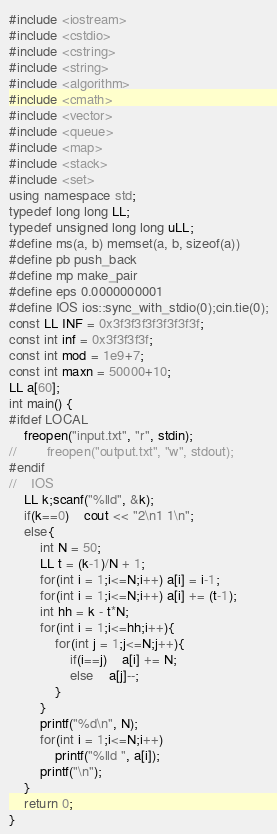<code> <loc_0><loc_0><loc_500><loc_500><_C++_>#include <iostream>
#include <cstdio>
#include <cstring>
#include <string>
#include <algorithm>
#include <cmath>
#include <vector>
#include <queue>
#include <map>
#include <stack>
#include <set>
using namespace std;
typedef long long LL;
typedef unsigned long long uLL;
#define ms(a, b) memset(a, b, sizeof(a))
#define pb push_back
#define mp make_pair
#define eps 0.0000000001
#define IOS ios::sync_with_stdio(0);cin.tie(0);
const LL INF = 0x3f3f3f3f3f3f3f3f;
const int inf = 0x3f3f3f3f;
const int mod = 1e9+7;
const int maxn = 50000+10;
LL a[60];
int main() {
#ifdef LOCAL
    freopen("input.txt", "r", stdin);
//        freopen("output.txt", "w", stdout);
#endif
//    IOS
    LL k;scanf("%lld", &k);
    if(k==0)    cout << "2\n1 1\n";
    else{
        int N = 50;
        LL t = (k-1)/N + 1;
        for(int i = 1;i<=N;i++) a[i] = i-1;
        for(int i = 1;i<=N;i++) a[i] += (t-1);
        int hh = k - t*N;
        for(int i = 1;i<=hh;i++){
            for(int j = 1;j<=N;j++){
                if(i==j)    a[i] += N;
                else    a[j]--;
            }
        }
        printf("%d\n", N);
        for(int i = 1;i<=N;i++)
            printf("%lld ", a[i]);
        printf("\n");
    }
    return 0;
}
</code> 